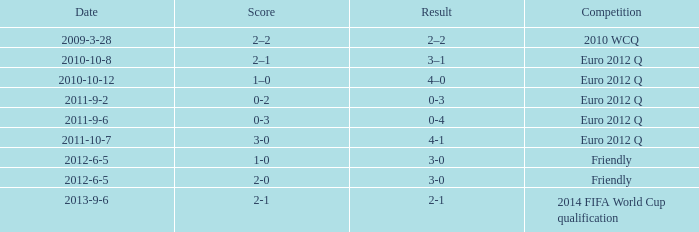How many goals when the score is 3-0 in the euro 2012 q? 1.0. 